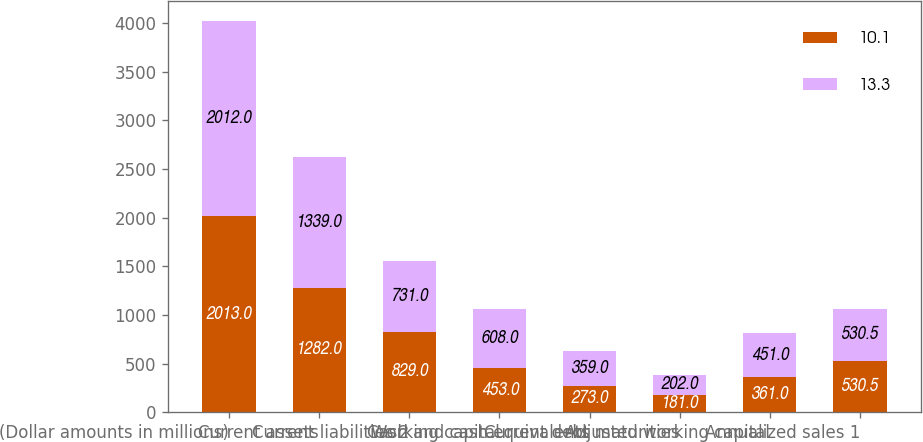Convert chart to OTSL. <chart><loc_0><loc_0><loc_500><loc_500><stacked_bar_chart><ecel><fcel>(Dollar amounts in millions)<fcel>Current assets<fcel>Current liabilities 2<fcel>Working capital<fcel>Cash and cash equivalents<fcel>Current debt maturities<fcel>Adjusted working capital<fcel>Annualized sales 1<nl><fcel>10.1<fcel>2013<fcel>1282<fcel>829<fcel>453<fcel>273<fcel>181<fcel>361<fcel>530.5<nl><fcel>13.3<fcel>2012<fcel>1339<fcel>731<fcel>608<fcel>359<fcel>202<fcel>451<fcel>530.5<nl></chart> 